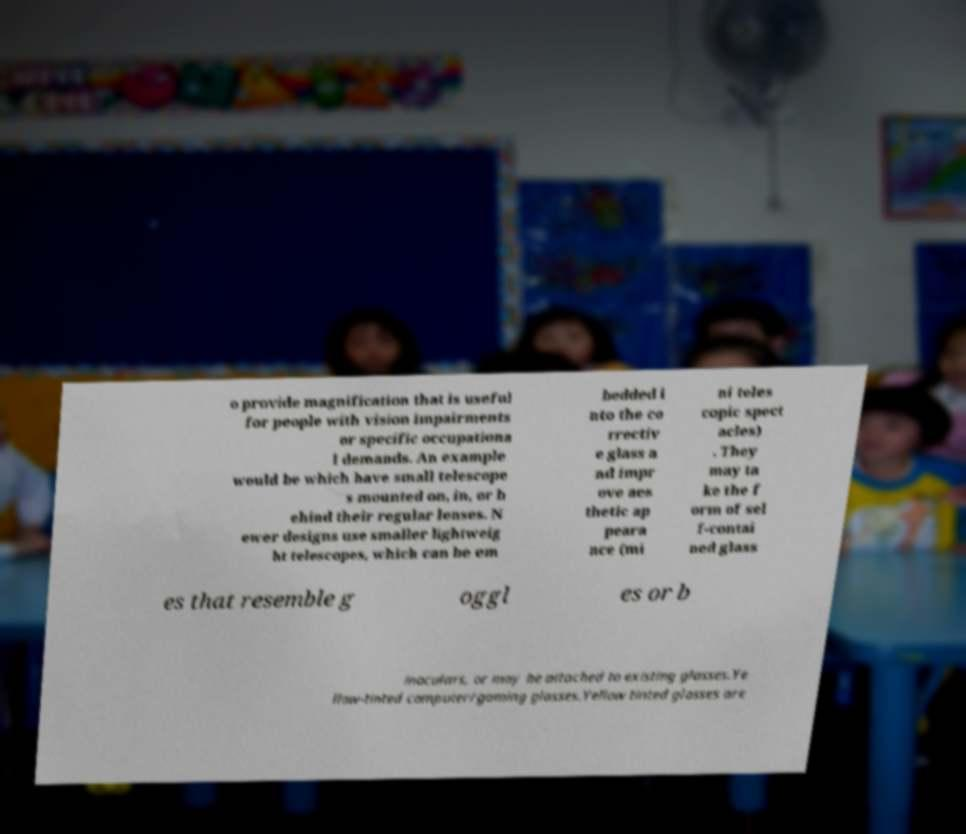Can you accurately transcribe the text from the provided image for me? o provide magnification that is useful for people with vision impairments or specific occupationa l demands. An example would be which have small telescope s mounted on, in, or b ehind their regular lenses. N ewer designs use smaller lightweig ht telescopes, which can be em bedded i nto the co rrectiv e glass a nd impr ove aes thetic ap peara nce (mi ni teles copic spect acles) . They may ta ke the f orm of sel f-contai ned glass es that resemble g oggl es or b inoculars, or may be attached to existing glasses.Ye llow-tinted computer/gaming glasses.Yellow tinted glasses are 